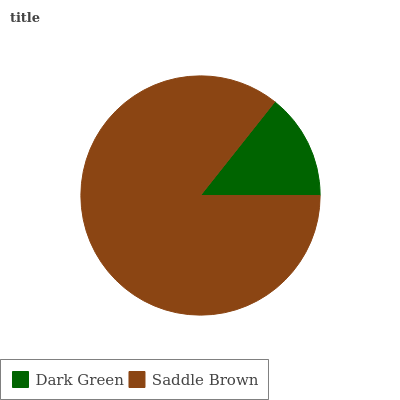Is Dark Green the minimum?
Answer yes or no. Yes. Is Saddle Brown the maximum?
Answer yes or no. Yes. Is Saddle Brown the minimum?
Answer yes or no. No. Is Saddle Brown greater than Dark Green?
Answer yes or no. Yes. Is Dark Green less than Saddle Brown?
Answer yes or no. Yes. Is Dark Green greater than Saddle Brown?
Answer yes or no. No. Is Saddle Brown less than Dark Green?
Answer yes or no. No. Is Saddle Brown the high median?
Answer yes or no. Yes. Is Dark Green the low median?
Answer yes or no. Yes. Is Dark Green the high median?
Answer yes or no. No. Is Saddle Brown the low median?
Answer yes or no. No. 